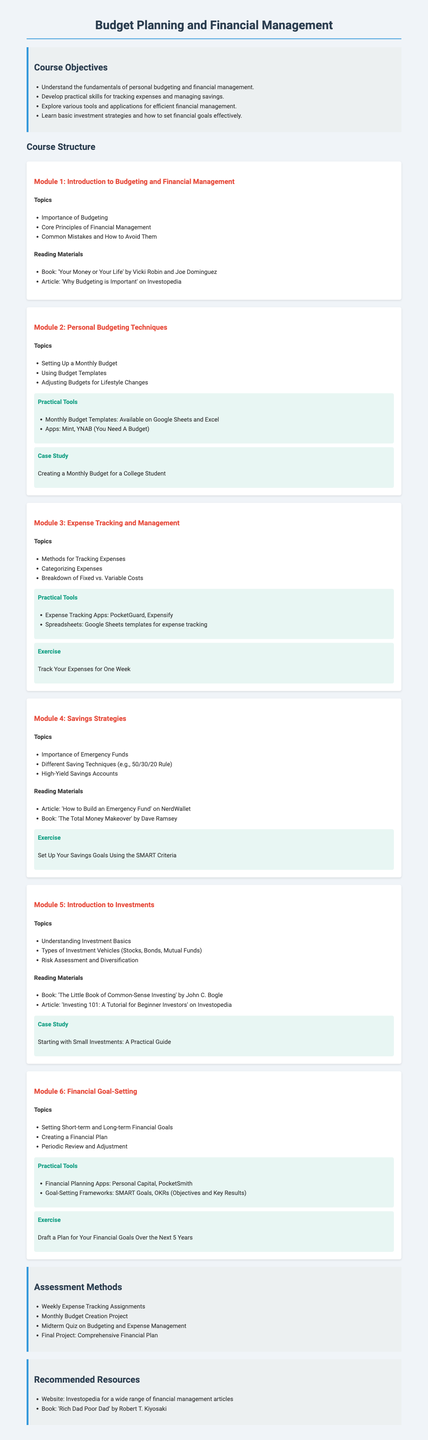What is the title of the syllabus? The title of the syllabus is prominently displayed at the top of the document.
Answer: Budget Planning and Financial Management How many modules are in the course structure? The course structure includes multiple modules, and a count can be determined by reviewing the document's sections.
Answer: 6 What is one practical tool mentioned for personal budgeting? The document lists practical tools within the modules, specifically stating examples.
Answer: Mint Name one book from the reading materials in Module 4 Each module includes specific reading materials, and one can be identified from the list in Module 4.
Answer: The Total Money Makeover What exercise is associated with Module 6? Each module contains exercises, and by checking Module 6, we can find the specific task assigned.
Answer: Draft a Plan for Your Financial Goals Over the Next 5 Years What is the financial goal-setting framework mentioned in Module 6? The syllabus refers to specific frameworks for goal-setting in the related module.
Answer: SMART Goals Which article is recommended reading for Module 1? The document provides titles for reading materials in each module, including Module 1.
Answer: Why Budgeting is Important What type of assessment involves creating a comprehensive financial plan? The document outlines various assessment methods, and one corresponds to a final project.
Answer: Final Project: Comprehensive Financial Plan 